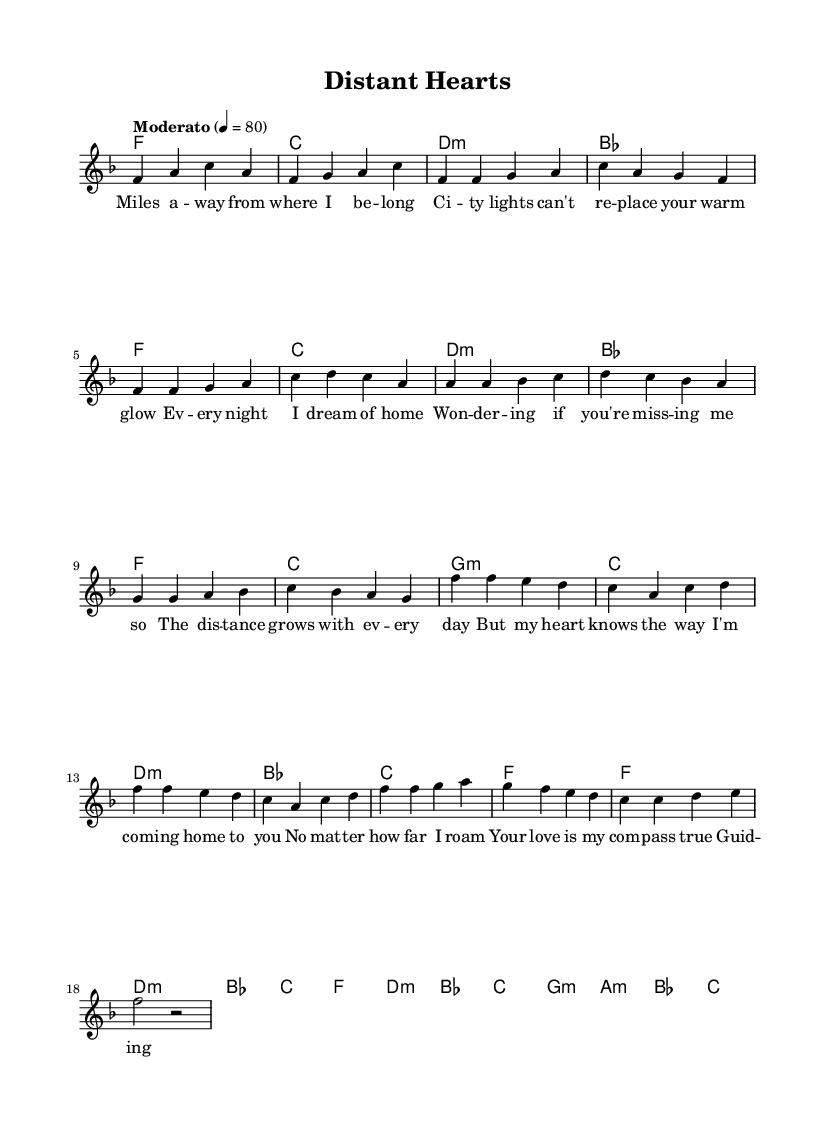What is the key signature of this music? The key signature is F major, which has one flat (B flat). This can be identified by looking at the key signature indicated at the beginning of the sheet music.
Answer: F major What is the time signature of this piece? The time signature is 4/4, which indicates that there are four beats in each measure and a quarter note receives one beat. This can be observed in the time signature placed at the beginning of the sheet music.
Answer: 4/4 What is the tempo marking for this music? The tempo marking is "Moderato", which generally indicates a moderate pace. It is shown above the staff where the tempo is set to 80 beats per minute.
Answer: Moderato How many measures are in the chorus section? The chorus section contains 8 measures. By counting the measures within the bracketed section of the music labeled as "Chorus", we can determine the total.
Answer: 8 What emotion does this ballad primarily convey? The ballad primarily conveys a sense of longing and homesickness. The lyrics express feelings of missing home and loved ones, which aligns with the themes typically found in K-Pop ballads.
Answer: Longing Which musical form is utilized in this piece? The piece employs a verse-pre-chorus-chorus structure, which is a common form found in K-Pop music. By analyzing the layout of the sections, we see the sequential relationship of the verse leading to the pre-chorus and then the chorus.
Answer: Verse-pre-chorus-chorus What type of chord progression starts the pre-chorus? The pre-chorus starts with a minor chord progression. This can be identified by looking at the chord symbols listed above the melody in the pre-chorus section.
Answer: Minor 